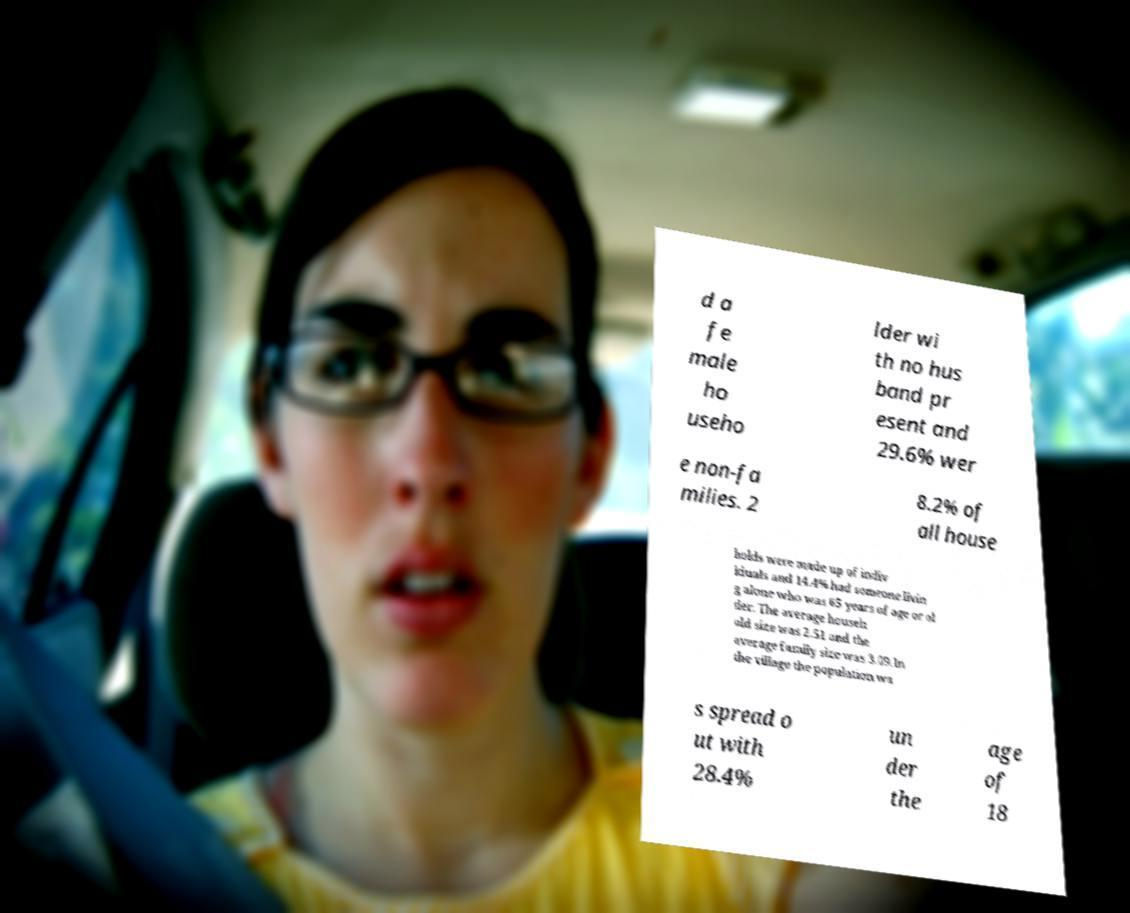There's text embedded in this image that I need extracted. Can you transcribe it verbatim? d a fe male ho useho lder wi th no hus band pr esent and 29.6% wer e non-fa milies. 2 8.2% of all house holds were made up of indiv iduals and 14.4% had someone livin g alone who was 65 years of age or ol der. The average househ old size was 2.51 and the average family size was 3.09.In the village the population wa s spread o ut with 28.4% un der the age of 18 